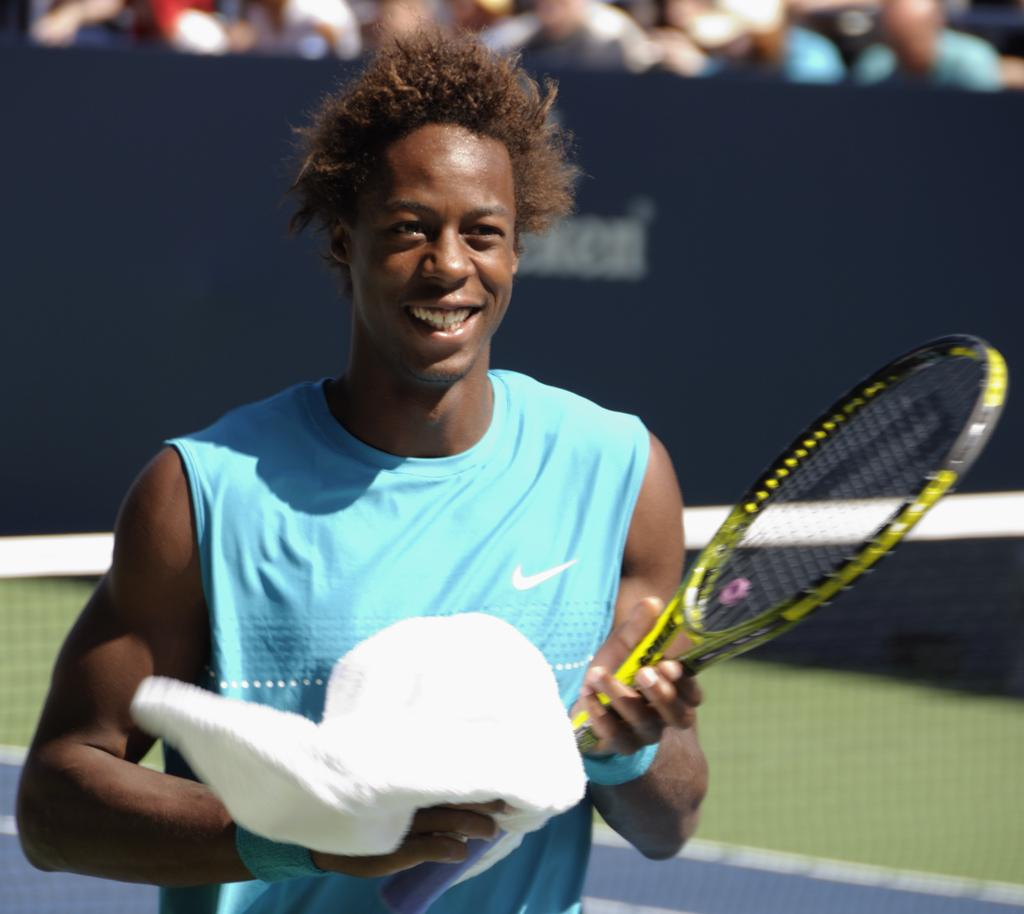What is the main subject of the image? There is a boy in the center of the image. What is the boy holding in his hands? The boy is holding a towel and a tennis bat. Are there any other people visible in the image? Yes, there are people at the top side of the image. What type of jelly can be seen on the tennis bat in the image? There is no jelly present on the tennis bat in the image. What kind of patch is visible on the boy's clothing? There is no patch visible on the boy's clothing in the image. 